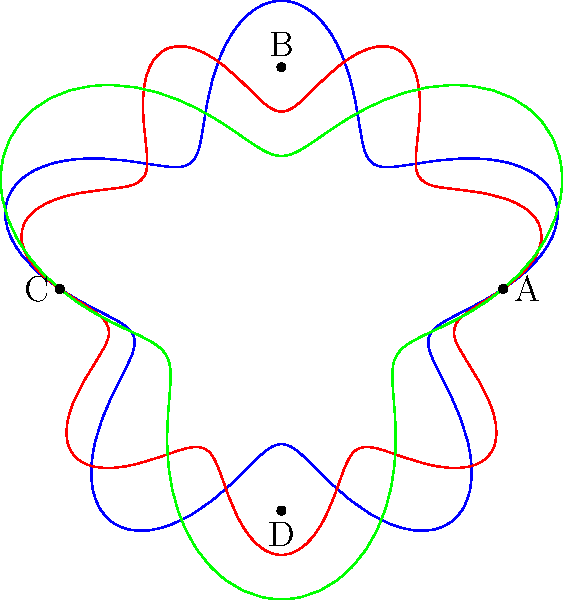In the polar coordinate plot above, three spiral patterns represent the narrative structures of different religious texts. The blue spiral (with 5 peaks) represents the Bhagavad Gita, the red spiral (with 7 peaks) represents the Book of Revelation, and the green spiral (with 3 peaks) represents the Tao Te Ching. Which text, based on this representation, has the most cyclical or repetitive narrative structure? To determine which text has the most cyclical or repetitive narrative structure, we need to analyze the spiral patterns:

1. Blue spiral (Bhagavad Gita):
   - Has 5 peaks
   - Moderate amplitude variations

2. Red spiral (Book of Revelation):
   - Has 7 peaks
   - Smallest amplitude variations

3. Green spiral (Tao Te Ching):
   - Has 3 peaks
   - Largest amplitude variations

The number of peaks indicates the frequency of repetition or cycles in the narrative structure. More peaks suggest a more frequently repeating structure.

The amplitude of the variations represents the degree of deviation from a perfect circle. Smaller variations indicate a more consistent, cyclical structure.

Based on these observations:

1. The Book of Revelation (red spiral) has the most peaks (7) and the smallest amplitude variations, suggesting the most frequent and consistent repetition in its narrative structure.

2. The Bhagavad Gita (blue spiral) has a moderate number of peaks (5) and moderate amplitude variations, indicating a somewhat cyclical structure but less so than the Book of Revelation.

3. The Tao Te Ching (green spiral) has the fewest peaks (3) and the largest amplitude variations, suggesting the least cyclical structure among the three.

Therefore, the Book of Revelation, represented by the red spiral, has the most cyclical or repetitive narrative structure.
Answer: Book of Revelation 